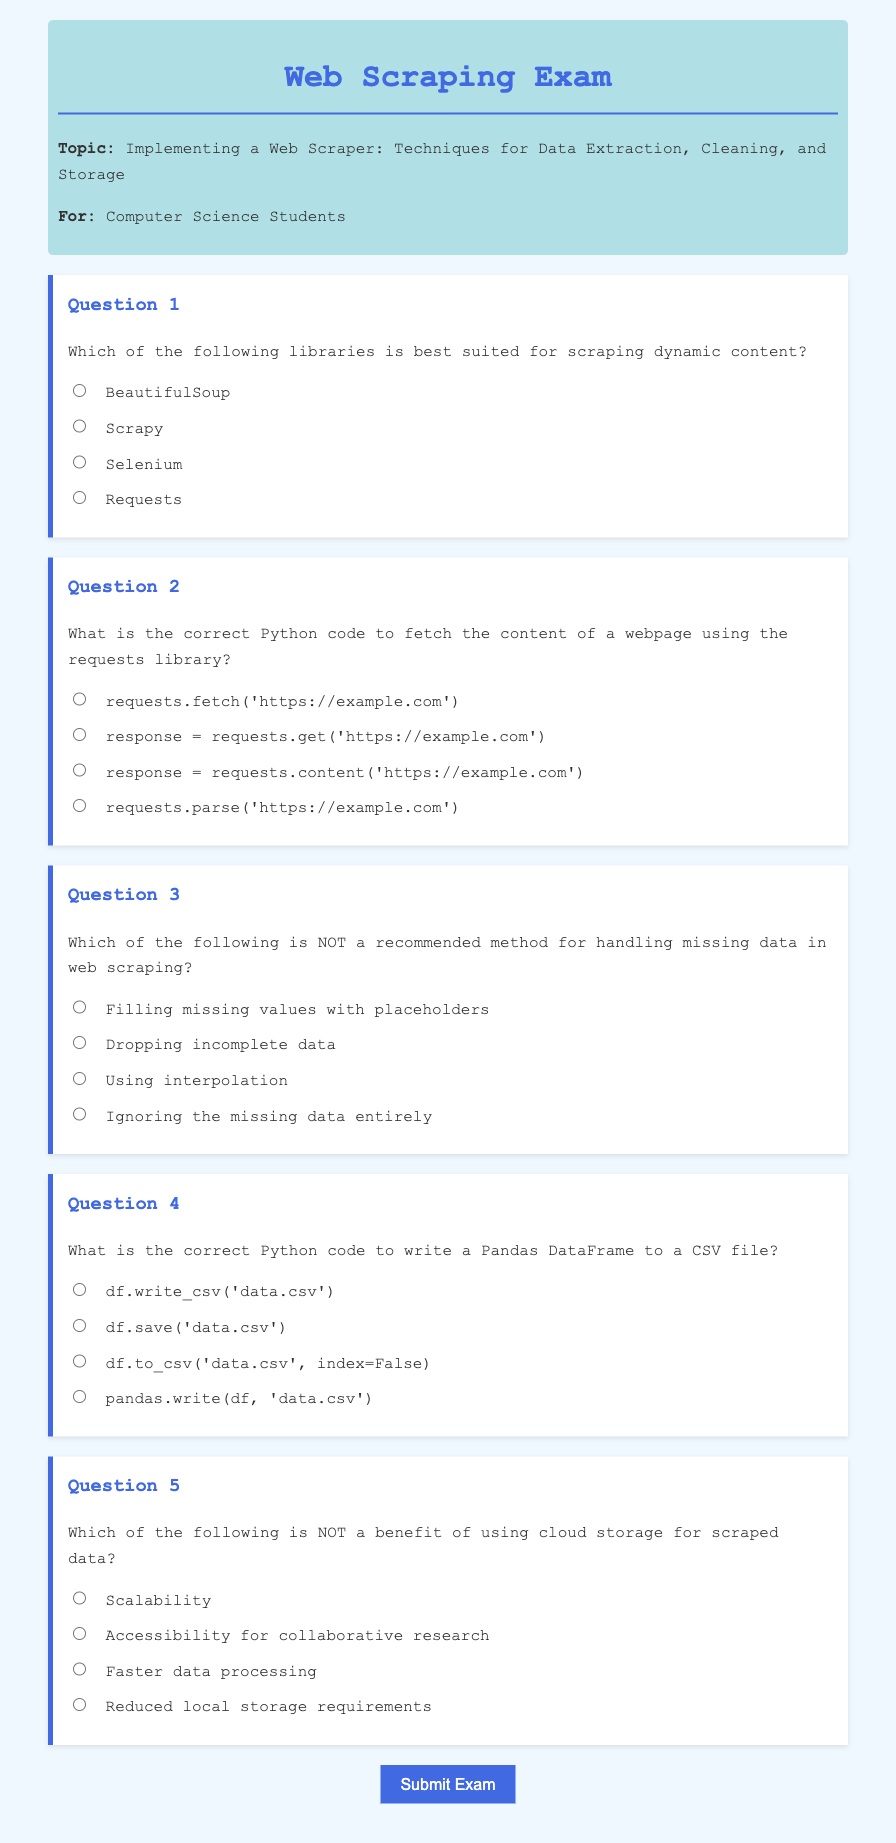What is the title of the exam? The title of the exam is provided in the document, which is "Web Scraping Exam."
Answer: Web Scraping Exam What is the main topic of this exam? The topic is listed right after the title, which is about implementing web scrapers for data extraction, cleaning, and storage.
Answer: Implementing a Web Scraper: Techniques for Data Extraction, Cleaning, and Storage Which library is best for scraping dynamic content? The answer to this question can be found in Question 1 options where Selenium is specified as the best suited library for dynamic content.
Answer: Selenium What is the Python code to fetch webpage content? This information is given in Question 2, where "response = requests.get('https://example.com')" is the correct option.
Answer: response = requests.get('https://example.com') What is NOT a recommended method for handling missing data? The answer is provided in Question 3 options, indicating that ignoring missing data entirely is not recommended.
Answer: Ignoring the missing data entirely What is the correct code to write a DataFrame to a CSV file? Question 4 provides the answer as "df.to_csv('data.csv', index=False)" which is the correct method.
Answer: df.to_csv('data.csv', index=False) Which benefit is NOT associated with cloud storage for scraped data? Question 5 outlines various benefits, with "Faster data processing" being indicated as NOT a benefit.
Answer: Faster data processing 